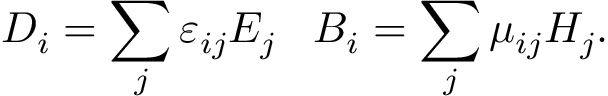<formula> <loc_0><loc_0><loc_500><loc_500>D _ { i } = \sum _ { j } \varepsilon _ { i j } E _ { j } \, B _ { i } = \sum _ { j } \mu _ { i j } H _ { j } .</formula> 